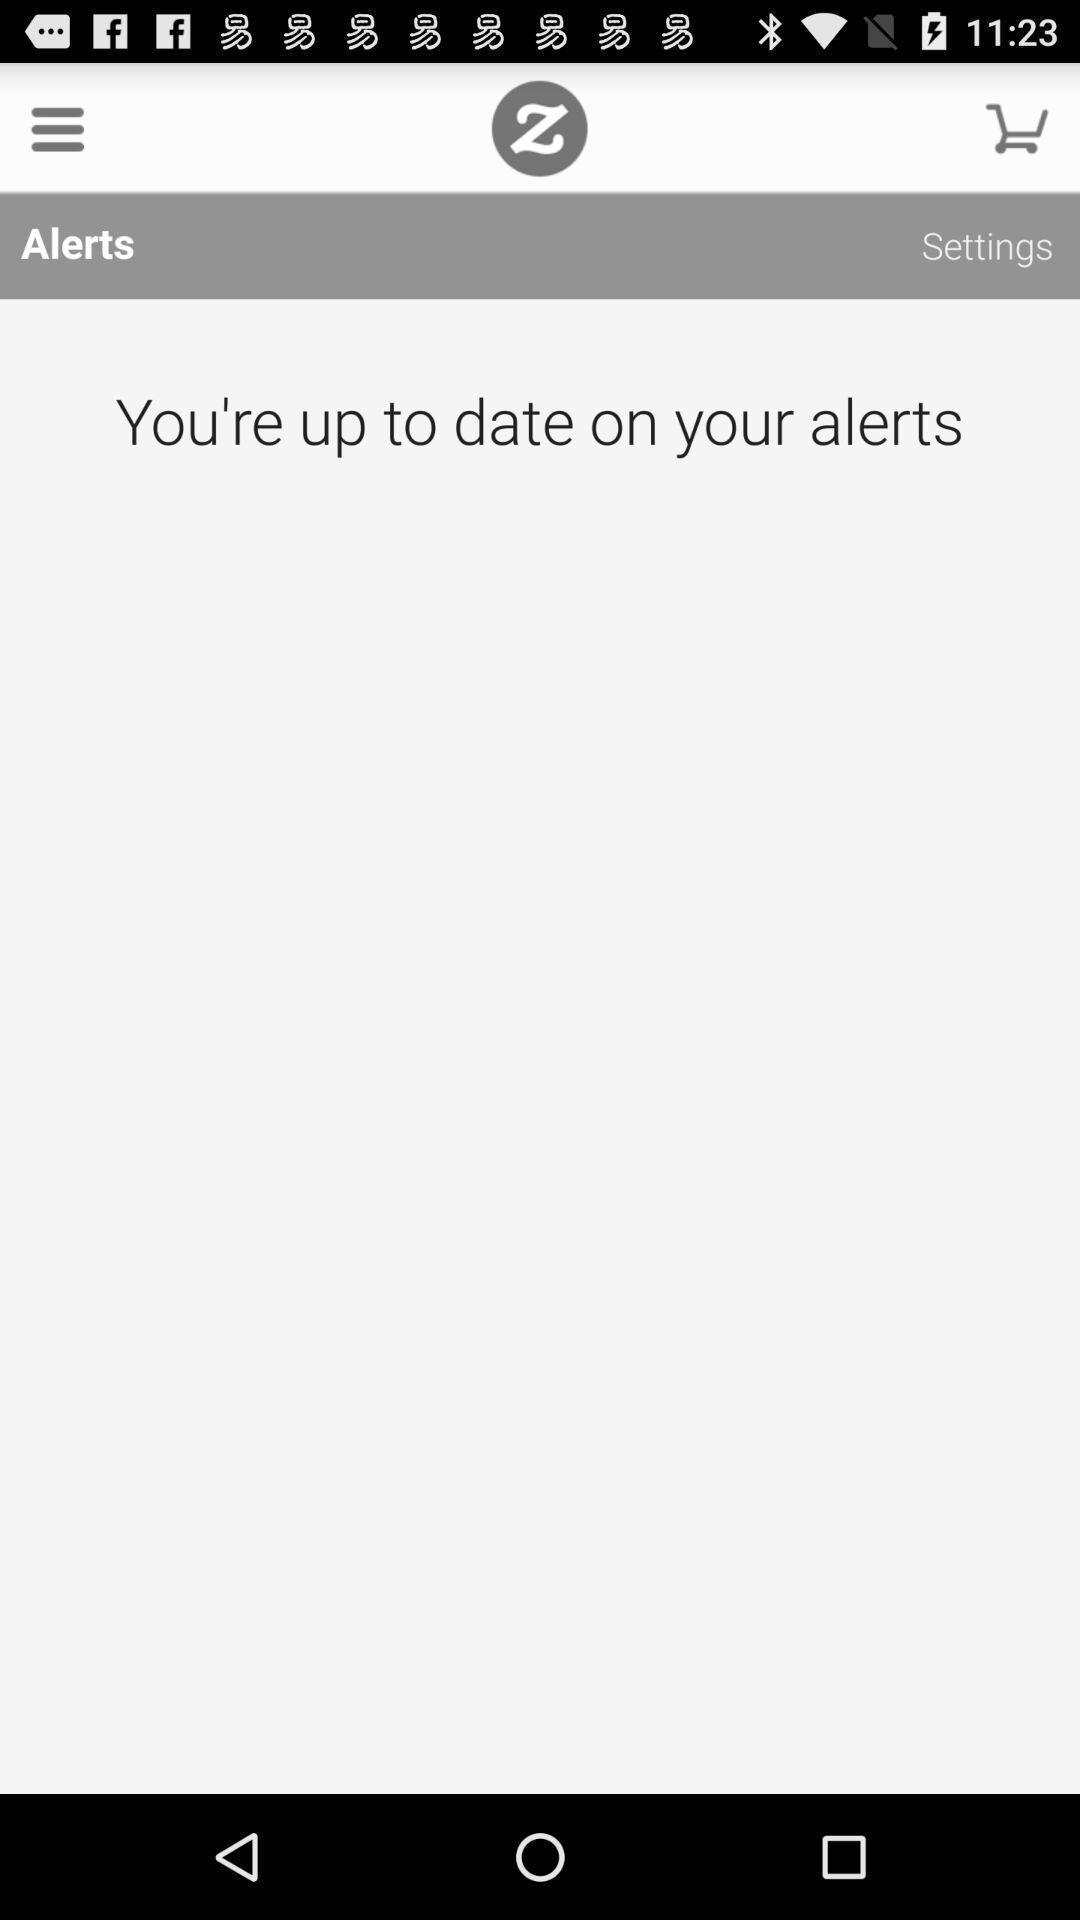Summarize the main components in this picture. Screen displaying alerts page. 